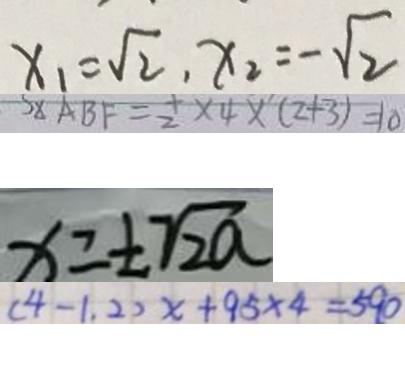<formula> <loc_0><loc_0><loc_500><loc_500>x _ { 1 } = \sqrt { 2 } , x _ { 2 } = - \sqrt { 2 } 
 S _ { \Delta A B F } = \frac { 1 } { 2 } \times 4 \times ( 2 + 3 ) = 1 0 
 x = \pm \sqrt { 2 a } 
 ( 4 - 1 . 2 ) x + 9 5 \times 4 = 5 9 0</formula> 